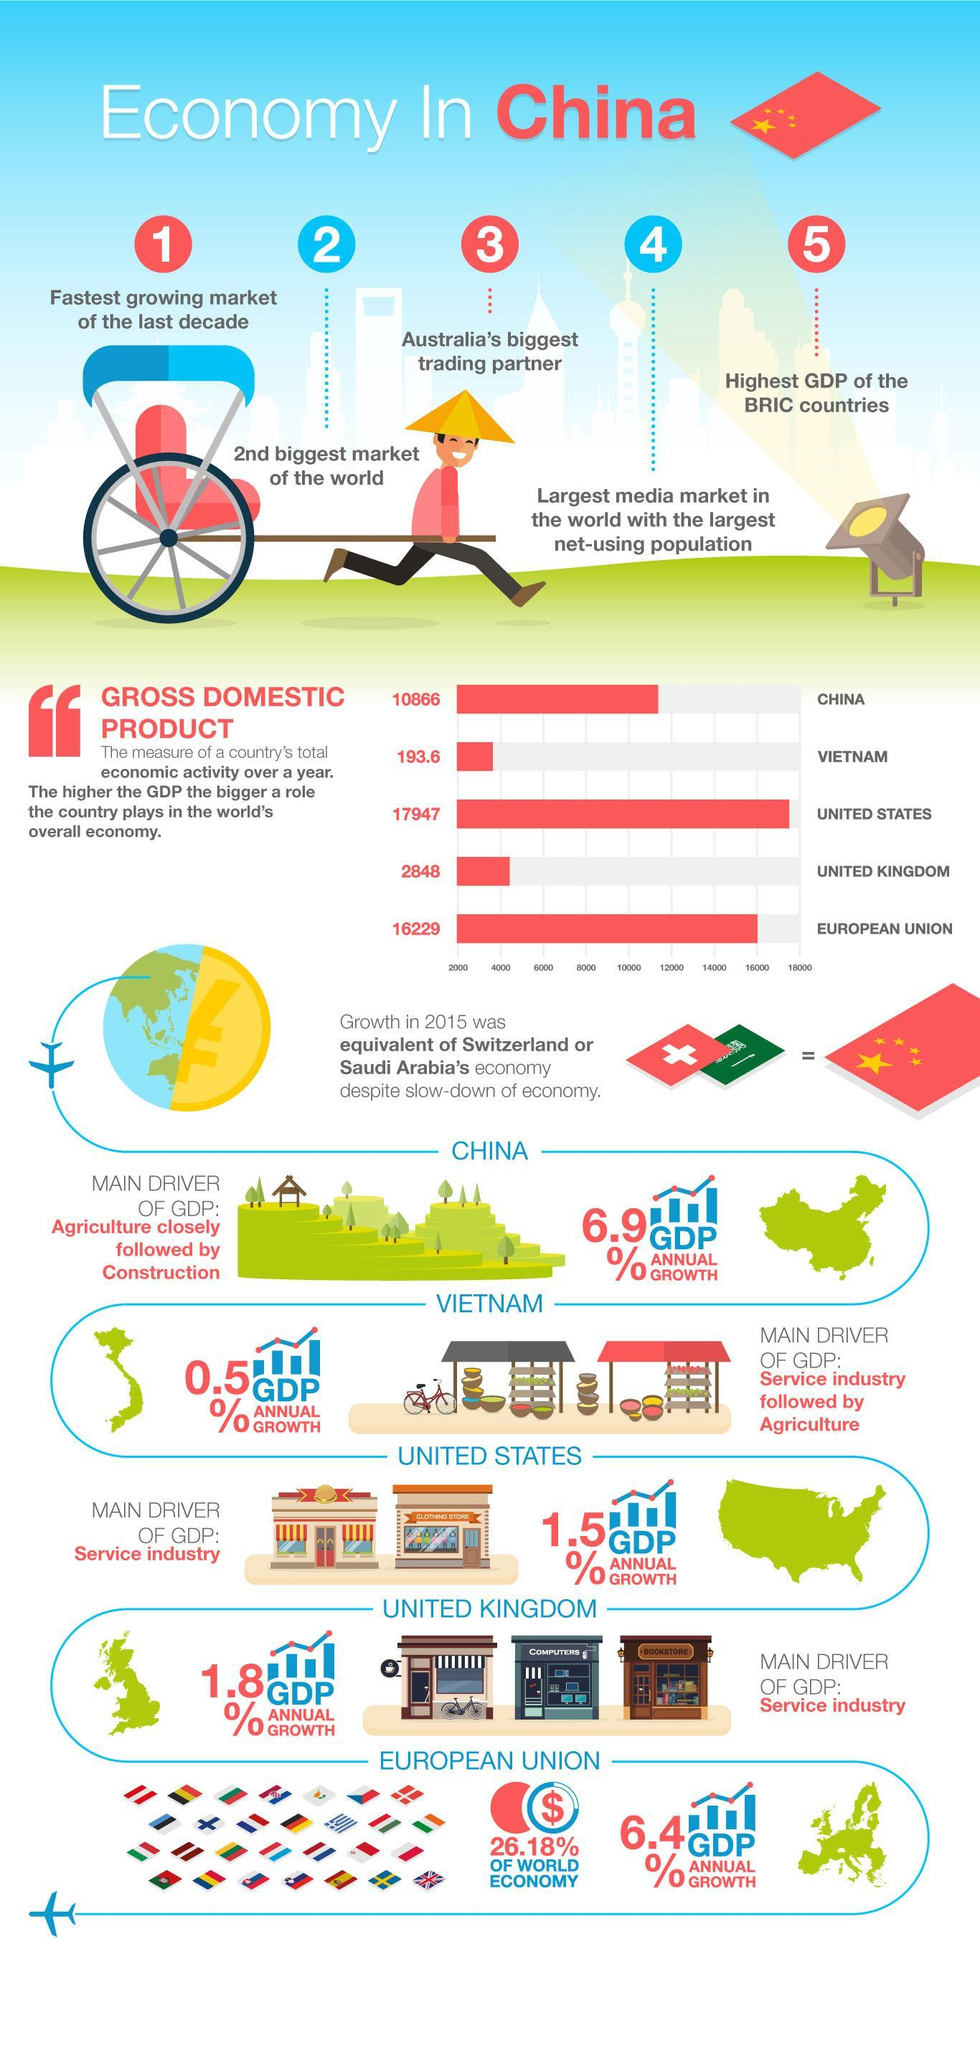Which country comes in first in its contribution to the World's overall economy?
Answer the question with a short phrase. United States Which country comes in fourth in its contribution to the World's overall economy? United Kingdom How much more of GDP growth did China see annually than GDP growth in United States? 5.4% Which country comes in third in its contribution to the World's overall economy? China Which industry contributed the most in driving the annual growth of GDP of United Kingdom? Service Industry Which industry contributed the most in driving the annual growth of GDP of Vietnam? Service Industry Which industry contributed the second most in driving the annual growth of GDP of China? construction Which country leads in usage of net? China Which industry contributed the most in driving the annual growth of GDP of China? agriculture Economic growth in China tallied with which countries in 2015? Switzerland,Saudi Arabia 